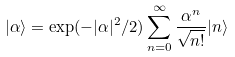<formula> <loc_0><loc_0><loc_500><loc_500>| \alpha \rangle = \exp ( - | \alpha | ^ { 2 } / 2 ) \sum _ { n = 0 } ^ { \infty } \frac { \alpha ^ { n } } { \sqrt { n ! } } | n \rangle</formula> 